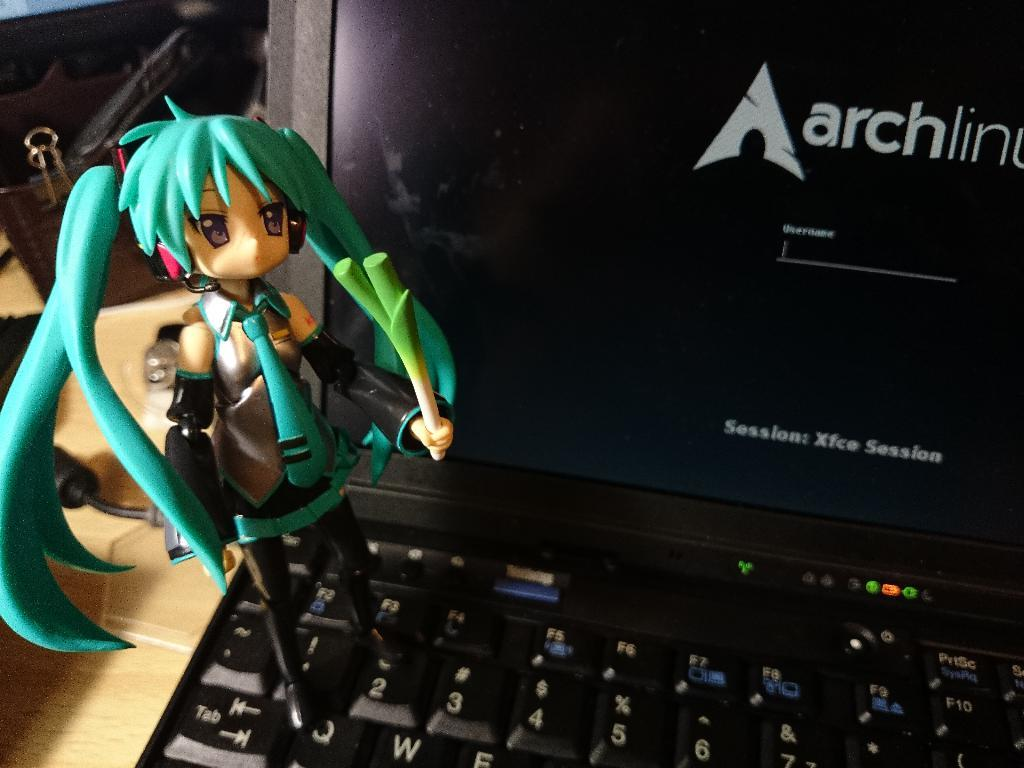What is the main subject in the center of the image? There is a toy in the center of the image. Where is the toy placed? The toy is on a laptop. Can you describe the background of the image? There are other objects on a table in the background of the image. What type of haircut is the toy getting in the image? There is no haircut present in the image; it features a toy on a laptop. Can you see a rifle or cannon in the image? There is no rifle or cannon present in the image. 